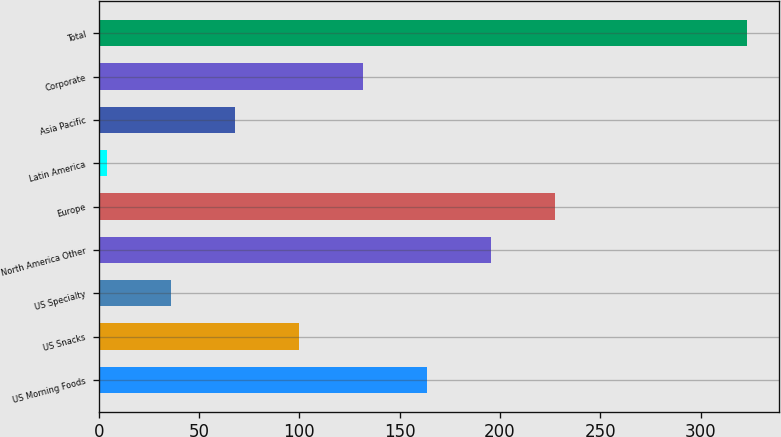Convert chart to OTSL. <chart><loc_0><loc_0><loc_500><loc_500><bar_chart><fcel>US Morning Foods<fcel>US Snacks<fcel>US Specialty<fcel>North America Other<fcel>Europe<fcel>Latin America<fcel>Asia Pacific<fcel>Corporate<fcel>Total<nl><fcel>163.5<fcel>99.7<fcel>35.9<fcel>195.4<fcel>227.3<fcel>4<fcel>67.8<fcel>131.6<fcel>323<nl></chart> 